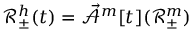<formula> <loc_0><loc_0><loc_500><loc_500>\ m a t h s c r { R } _ { \pm } ^ { h } ( t ) = \mathcal { \vec { A } } ^ { m } [ t ] ( \ m a t h s c r { R } _ { \pm } ^ { m } )</formula> 